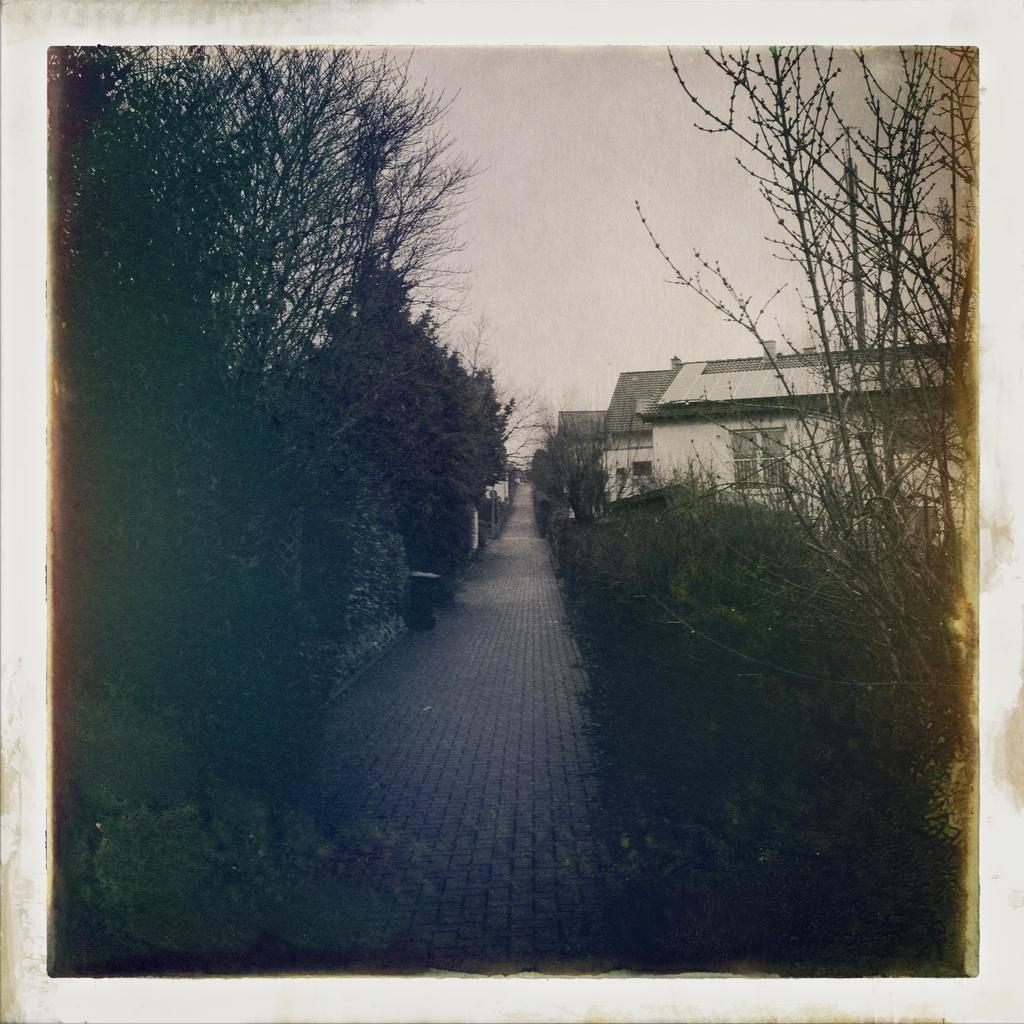What types of living organisms can be seen in the image? Plants and trees are visible in the image. What structures can be seen in the background of the image? There are houses in the background of the image. How does the zephyr affect the mist in the image? There is no mist or zephyr present in the image; it features plants, trees, and houses. 